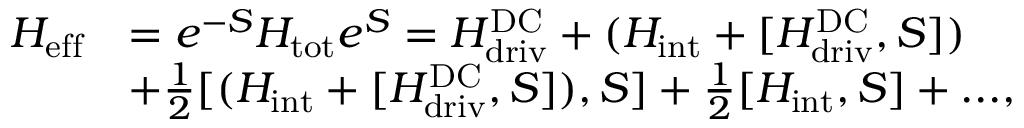Convert formula to latex. <formula><loc_0><loc_0><loc_500><loc_500>\begin{array} { r l } { H _ { e f f } } & { = { e ^ { - S } } H _ { t o t } { e ^ { S } } = H _ { d r i v } ^ { D C } + ( H _ { i n t } + [ H _ { d r i v } ^ { D C } , S ] ) } \\ & { + \frac { 1 } { 2 } [ ( H _ { i n t } + [ H _ { d r i v } ^ { D C } , S ] ) , S ] + \frac { 1 } { 2 } [ H _ { i n t } , S ] + \dots , } \end{array}</formula> 